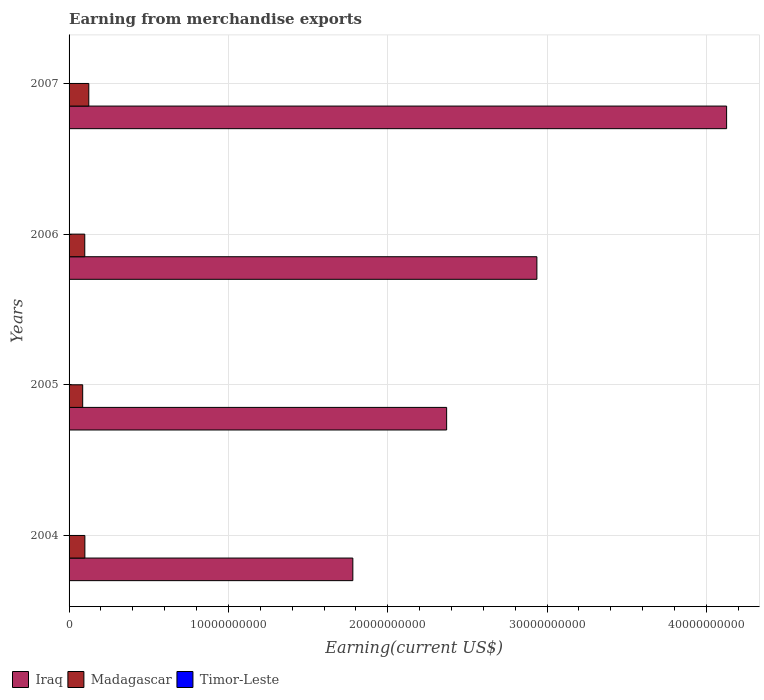How many different coloured bars are there?
Keep it short and to the point. 3. Are the number of bars on each tick of the Y-axis equal?
Your answer should be very brief. Yes. How many bars are there on the 4th tick from the top?
Keep it short and to the point. 3. How many bars are there on the 3rd tick from the bottom?
Provide a succinct answer. 3. What is the amount earned from merchandise exports in Iraq in 2007?
Offer a terse response. 4.13e+1. Across all years, what is the maximum amount earned from merchandise exports in Timor-Leste?
Your response must be concise. 8.44e+06. Across all years, what is the minimum amount earned from merchandise exports in Madagascar?
Provide a short and direct response. 8.55e+08. In which year was the amount earned from merchandise exports in Madagascar maximum?
Your answer should be very brief. 2007. In which year was the amount earned from merchandise exports in Madagascar minimum?
Your answer should be very brief. 2005. What is the total amount earned from merchandise exports in Madagascar in the graph?
Your answer should be very brief. 4.07e+09. What is the difference between the amount earned from merchandise exports in Timor-Leste in 2006 and that in 2007?
Your answer should be compact. 7.70e+04. What is the difference between the amount earned from merchandise exports in Timor-Leste in 2006 and the amount earned from merchandise exports in Iraq in 2007?
Make the answer very short. -4.13e+1. What is the average amount earned from merchandise exports in Iraq per year?
Give a very brief answer. 2.80e+1. In the year 2006, what is the difference between the amount earned from merchandise exports in Timor-Leste and amount earned from merchandise exports in Madagascar?
Make the answer very short. -9.77e+08. In how many years, is the amount earned from merchandise exports in Iraq greater than 4000000000 US$?
Offer a terse response. 4. What is the ratio of the amount earned from merchandise exports in Madagascar in 2005 to that in 2007?
Offer a terse response. 0.69. Is the difference between the amount earned from merchandise exports in Timor-Leste in 2004 and 2005 greater than the difference between the amount earned from merchandise exports in Madagascar in 2004 and 2005?
Provide a short and direct response. No. What is the difference between the highest and the second highest amount earned from merchandise exports in Timor-Leste?
Offer a very short reply. 7.70e+04. What is the difference between the highest and the lowest amount earned from merchandise exports in Timor-Leste?
Ensure brevity in your answer.  1.11e+06. Is the sum of the amount earned from merchandise exports in Iraq in 2006 and 2007 greater than the maximum amount earned from merchandise exports in Madagascar across all years?
Your answer should be very brief. Yes. What does the 3rd bar from the top in 2007 represents?
Offer a terse response. Iraq. What does the 3rd bar from the bottom in 2006 represents?
Offer a very short reply. Timor-Leste. Is it the case that in every year, the sum of the amount earned from merchandise exports in Madagascar and amount earned from merchandise exports in Iraq is greater than the amount earned from merchandise exports in Timor-Leste?
Provide a succinct answer. Yes. How many bars are there?
Your answer should be very brief. 12. What is the difference between two consecutive major ticks on the X-axis?
Give a very brief answer. 1.00e+1. Are the values on the major ticks of X-axis written in scientific E-notation?
Give a very brief answer. No. Does the graph contain grids?
Give a very brief answer. Yes. Where does the legend appear in the graph?
Offer a terse response. Bottom left. How are the legend labels stacked?
Offer a terse response. Horizontal. What is the title of the graph?
Provide a short and direct response. Earning from merchandise exports. Does "Korea (Republic)" appear as one of the legend labels in the graph?
Your response must be concise. No. What is the label or title of the X-axis?
Your answer should be very brief. Earning(current US$). What is the Earning(current US$) in Iraq in 2004?
Ensure brevity in your answer.  1.78e+1. What is the Earning(current US$) in Madagascar in 2004?
Provide a succinct answer. 9.92e+08. What is the Earning(current US$) in Timor-Leste in 2004?
Make the answer very short. 7.34e+06. What is the Earning(current US$) of Iraq in 2005?
Offer a terse response. 2.37e+1. What is the Earning(current US$) of Madagascar in 2005?
Ensure brevity in your answer.  8.55e+08. What is the Earning(current US$) in Timor-Leste in 2005?
Ensure brevity in your answer.  8.09e+06. What is the Earning(current US$) of Iraq in 2006?
Your answer should be very brief. 2.94e+1. What is the Earning(current US$) of Madagascar in 2006?
Provide a short and direct response. 9.85e+08. What is the Earning(current US$) in Timor-Leste in 2006?
Offer a terse response. 8.44e+06. What is the Earning(current US$) of Iraq in 2007?
Ensure brevity in your answer.  4.13e+1. What is the Earning(current US$) in Madagascar in 2007?
Your answer should be compact. 1.24e+09. What is the Earning(current US$) in Timor-Leste in 2007?
Offer a terse response. 8.37e+06. Across all years, what is the maximum Earning(current US$) in Iraq?
Provide a succinct answer. 4.13e+1. Across all years, what is the maximum Earning(current US$) in Madagascar?
Give a very brief answer. 1.24e+09. Across all years, what is the maximum Earning(current US$) in Timor-Leste?
Make the answer very short. 8.44e+06. Across all years, what is the minimum Earning(current US$) of Iraq?
Provide a succinct answer. 1.78e+1. Across all years, what is the minimum Earning(current US$) in Madagascar?
Your answer should be very brief. 8.55e+08. Across all years, what is the minimum Earning(current US$) of Timor-Leste?
Ensure brevity in your answer.  7.34e+06. What is the total Earning(current US$) of Iraq in the graph?
Offer a terse response. 1.12e+11. What is the total Earning(current US$) in Madagascar in the graph?
Offer a terse response. 4.07e+09. What is the total Earning(current US$) in Timor-Leste in the graph?
Provide a short and direct response. 3.22e+07. What is the difference between the Earning(current US$) of Iraq in 2004 and that in 2005?
Your response must be concise. -5.89e+09. What is the difference between the Earning(current US$) in Madagascar in 2004 and that in 2005?
Provide a short and direct response. 1.37e+08. What is the difference between the Earning(current US$) in Timor-Leste in 2004 and that in 2005?
Provide a succinct answer. -7.50e+05. What is the difference between the Earning(current US$) in Iraq in 2004 and that in 2006?
Make the answer very short. -1.16e+1. What is the difference between the Earning(current US$) of Madagascar in 2004 and that in 2006?
Offer a very short reply. 6.36e+06. What is the difference between the Earning(current US$) in Timor-Leste in 2004 and that in 2006?
Your answer should be compact. -1.11e+06. What is the difference between the Earning(current US$) of Iraq in 2004 and that in 2007?
Your response must be concise. -2.35e+1. What is the difference between the Earning(current US$) of Madagascar in 2004 and that in 2007?
Provide a succinct answer. -2.46e+08. What is the difference between the Earning(current US$) in Timor-Leste in 2004 and that in 2007?
Your answer should be compact. -1.03e+06. What is the difference between the Earning(current US$) in Iraq in 2005 and that in 2006?
Give a very brief answer. -5.66e+09. What is the difference between the Earning(current US$) of Madagascar in 2005 and that in 2006?
Provide a succinct answer. -1.31e+08. What is the difference between the Earning(current US$) in Timor-Leste in 2005 and that in 2006?
Your response must be concise. -3.58e+05. What is the difference between the Earning(current US$) of Iraq in 2005 and that in 2007?
Offer a very short reply. -1.76e+1. What is the difference between the Earning(current US$) in Madagascar in 2005 and that in 2007?
Make the answer very short. -3.83e+08. What is the difference between the Earning(current US$) of Timor-Leste in 2005 and that in 2007?
Make the answer very short. -2.81e+05. What is the difference between the Earning(current US$) of Iraq in 2006 and that in 2007?
Offer a terse response. -1.19e+1. What is the difference between the Earning(current US$) in Madagascar in 2006 and that in 2007?
Your answer should be compact. -2.52e+08. What is the difference between the Earning(current US$) in Timor-Leste in 2006 and that in 2007?
Your answer should be very brief. 7.70e+04. What is the difference between the Earning(current US$) of Iraq in 2004 and the Earning(current US$) of Madagascar in 2005?
Your answer should be very brief. 1.70e+1. What is the difference between the Earning(current US$) in Iraq in 2004 and the Earning(current US$) in Timor-Leste in 2005?
Offer a terse response. 1.78e+1. What is the difference between the Earning(current US$) in Madagascar in 2004 and the Earning(current US$) in Timor-Leste in 2005?
Offer a terse response. 9.84e+08. What is the difference between the Earning(current US$) of Iraq in 2004 and the Earning(current US$) of Madagascar in 2006?
Your answer should be very brief. 1.68e+1. What is the difference between the Earning(current US$) of Iraq in 2004 and the Earning(current US$) of Timor-Leste in 2006?
Provide a short and direct response. 1.78e+1. What is the difference between the Earning(current US$) of Madagascar in 2004 and the Earning(current US$) of Timor-Leste in 2006?
Your answer should be very brief. 9.83e+08. What is the difference between the Earning(current US$) in Iraq in 2004 and the Earning(current US$) in Madagascar in 2007?
Your answer should be very brief. 1.66e+1. What is the difference between the Earning(current US$) of Iraq in 2004 and the Earning(current US$) of Timor-Leste in 2007?
Keep it short and to the point. 1.78e+1. What is the difference between the Earning(current US$) of Madagascar in 2004 and the Earning(current US$) of Timor-Leste in 2007?
Give a very brief answer. 9.83e+08. What is the difference between the Earning(current US$) in Iraq in 2005 and the Earning(current US$) in Madagascar in 2006?
Offer a terse response. 2.27e+1. What is the difference between the Earning(current US$) of Iraq in 2005 and the Earning(current US$) of Timor-Leste in 2006?
Make the answer very short. 2.37e+1. What is the difference between the Earning(current US$) in Madagascar in 2005 and the Earning(current US$) in Timor-Leste in 2006?
Give a very brief answer. 8.46e+08. What is the difference between the Earning(current US$) in Iraq in 2005 and the Earning(current US$) in Madagascar in 2007?
Provide a succinct answer. 2.25e+1. What is the difference between the Earning(current US$) in Iraq in 2005 and the Earning(current US$) in Timor-Leste in 2007?
Give a very brief answer. 2.37e+1. What is the difference between the Earning(current US$) in Madagascar in 2005 and the Earning(current US$) in Timor-Leste in 2007?
Your response must be concise. 8.46e+08. What is the difference between the Earning(current US$) in Iraq in 2006 and the Earning(current US$) in Madagascar in 2007?
Ensure brevity in your answer.  2.81e+1. What is the difference between the Earning(current US$) of Iraq in 2006 and the Earning(current US$) of Timor-Leste in 2007?
Provide a succinct answer. 2.94e+1. What is the difference between the Earning(current US$) in Madagascar in 2006 and the Earning(current US$) in Timor-Leste in 2007?
Give a very brief answer. 9.77e+08. What is the average Earning(current US$) of Iraq per year?
Your response must be concise. 2.80e+1. What is the average Earning(current US$) in Madagascar per year?
Provide a short and direct response. 1.02e+09. What is the average Earning(current US$) in Timor-Leste per year?
Your answer should be very brief. 8.06e+06. In the year 2004, what is the difference between the Earning(current US$) of Iraq and Earning(current US$) of Madagascar?
Keep it short and to the point. 1.68e+1. In the year 2004, what is the difference between the Earning(current US$) of Iraq and Earning(current US$) of Timor-Leste?
Offer a very short reply. 1.78e+1. In the year 2004, what is the difference between the Earning(current US$) of Madagascar and Earning(current US$) of Timor-Leste?
Ensure brevity in your answer.  9.84e+08. In the year 2005, what is the difference between the Earning(current US$) of Iraq and Earning(current US$) of Madagascar?
Your answer should be compact. 2.28e+1. In the year 2005, what is the difference between the Earning(current US$) in Iraq and Earning(current US$) in Timor-Leste?
Keep it short and to the point. 2.37e+1. In the year 2005, what is the difference between the Earning(current US$) in Madagascar and Earning(current US$) in Timor-Leste?
Provide a succinct answer. 8.47e+08. In the year 2006, what is the difference between the Earning(current US$) in Iraq and Earning(current US$) in Madagascar?
Provide a short and direct response. 2.84e+1. In the year 2006, what is the difference between the Earning(current US$) in Iraq and Earning(current US$) in Timor-Leste?
Keep it short and to the point. 2.94e+1. In the year 2006, what is the difference between the Earning(current US$) of Madagascar and Earning(current US$) of Timor-Leste?
Offer a terse response. 9.77e+08. In the year 2007, what is the difference between the Earning(current US$) of Iraq and Earning(current US$) of Madagascar?
Ensure brevity in your answer.  4.00e+1. In the year 2007, what is the difference between the Earning(current US$) in Iraq and Earning(current US$) in Timor-Leste?
Your answer should be very brief. 4.13e+1. In the year 2007, what is the difference between the Earning(current US$) in Madagascar and Earning(current US$) in Timor-Leste?
Offer a terse response. 1.23e+09. What is the ratio of the Earning(current US$) in Iraq in 2004 to that in 2005?
Keep it short and to the point. 0.75. What is the ratio of the Earning(current US$) in Madagascar in 2004 to that in 2005?
Your answer should be compact. 1.16. What is the ratio of the Earning(current US$) of Timor-Leste in 2004 to that in 2005?
Offer a terse response. 0.91. What is the ratio of the Earning(current US$) in Iraq in 2004 to that in 2006?
Your response must be concise. 0.61. What is the ratio of the Earning(current US$) in Madagascar in 2004 to that in 2006?
Provide a short and direct response. 1.01. What is the ratio of the Earning(current US$) of Timor-Leste in 2004 to that in 2006?
Give a very brief answer. 0.87. What is the ratio of the Earning(current US$) in Iraq in 2004 to that in 2007?
Your response must be concise. 0.43. What is the ratio of the Earning(current US$) of Madagascar in 2004 to that in 2007?
Ensure brevity in your answer.  0.8. What is the ratio of the Earning(current US$) in Timor-Leste in 2004 to that in 2007?
Give a very brief answer. 0.88. What is the ratio of the Earning(current US$) in Iraq in 2005 to that in 2006?
Keep it short and to the point. 0.81. What is the ratio of the Earning(current US$) in Madagascar in 2005 to that in 2006?
Provide a short and direct response. 0.87. What is the ratio of the Earning(current US$) of Timor-Leste in 2005 to that in 2006?
Your answer should be compact. 0.96. What is the ratio of the Earning(current US$) of Iraq in 2005 to that in 2007?
Your answer should be compact. 0.57. What is the ratio of the Earning(current US$) in Madagascar in 2005 to that in 2007?
Make the answer very short. 0.69. What is the ratio of the Earning(current US$) in Timor-Leste in 2005 to that in 2007?
Keep it short and to the point. 0.97. What is the ratio of the Earning(current US$) in Iraq in 2006 to that in 2007?
Provide a short and direct response. 0.71. What is the ratio of the Earning(current US$) in Madagascar in 2006 to that in 2007?
Give a very brief answer. 0.8. What is the ratio of the Earning(current US$) of Timor-Leste in 2006 to that in 2007?
Provide a succinct answer. 1.01. What is the difference between the highest and the second highest Earning(current US$) of Iraq?
Offer a terse response. 1.19e+1. What is the difference between the highest and the second highest Earning(current US$) in Madagascar?
Your answer should be very brief. 2.46e+08. What is the difference between the highest and the second highest Earning(current US$) of Timor-Leste?
Offer a terse response. 7.70e+04. What is the difference between the highest and the lowest Earning(current US$) in Iraq?
Give a very brief answer. 2.35e+1. What is the difference between the highest and the lowest Earning(current US$) in Madagascar?
Offer a very short reply. 3.83e+08. What is the difference between the highest and the lowest Earning(current US$) in Timor-Leste?
Offer a terse response. 1.11e+06. 